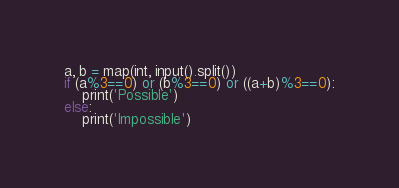<code> <loc_0><loc_0><loc_500><loc_500><_Python_>a, b = map(int, input().split())
if (a%3==0) or (b%3==0) or ((a+b)%3==0):
    print('Possible')
else:
    print('Impossible')</code> 